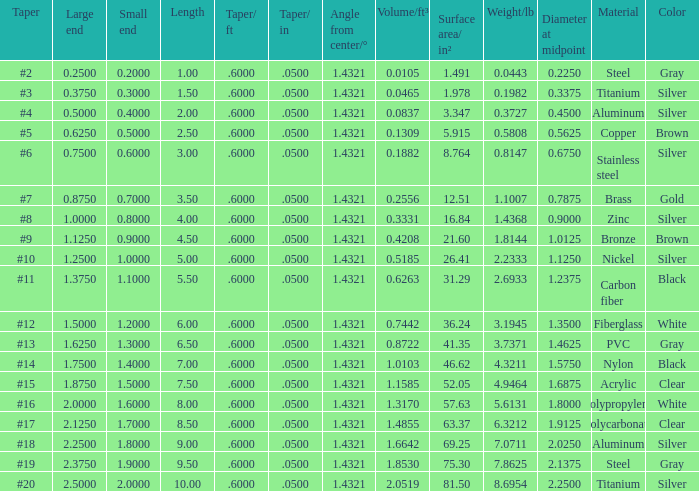Which Angle from center/° has a Taper/ft smaller than 0.6000000000000001? 19.0. 